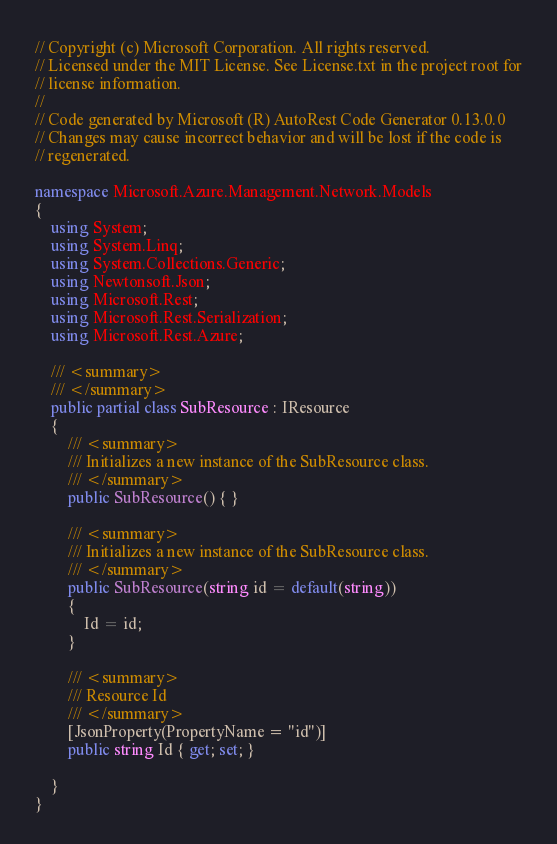<code> <loc_0><loc_0><loc_500><loc_500><_C#_>// Copyright (c) Microsoft Corporation. All rights reserved.
// Licensed under the MIT License. See License.txt in the project root for
// license information.
// 
// Code generated by Microsoft (R) AutoRest Code Generator 0.13.0.0
// Changes may cause incorrect behavior and will be lost if the code is
// regenerated.

namespace Microsoft.Azure.Management.Network.Models
{
    using System;
    using System.Linq;
    using System.Collections.Generic;
    using Newtonsoft.Json;
    using Microsoft.Rest;
    using Microsoft.Rest.Serialization;
    using Microsoft.Rest.Azure;

    /// <summary>
    /// </summary>
    public partial class SubResource : IResource
    {
        /// <summary>
        /// Initializes a new instance of the SubResource class.
        /// </summary>
        public SubResource() { }

        /// <summary>
        /// Initializes a new instance of the SubResource class.
        /// </summary>
        public SubResource(string id = default(string))
        {
            Id = id;
        }

        /// <summary>
        /// Resource Id
        /// </summary>
        [JsonProperty(PropertyName = "id")]
        public string Id { get; set; }

    }
}
</code> 